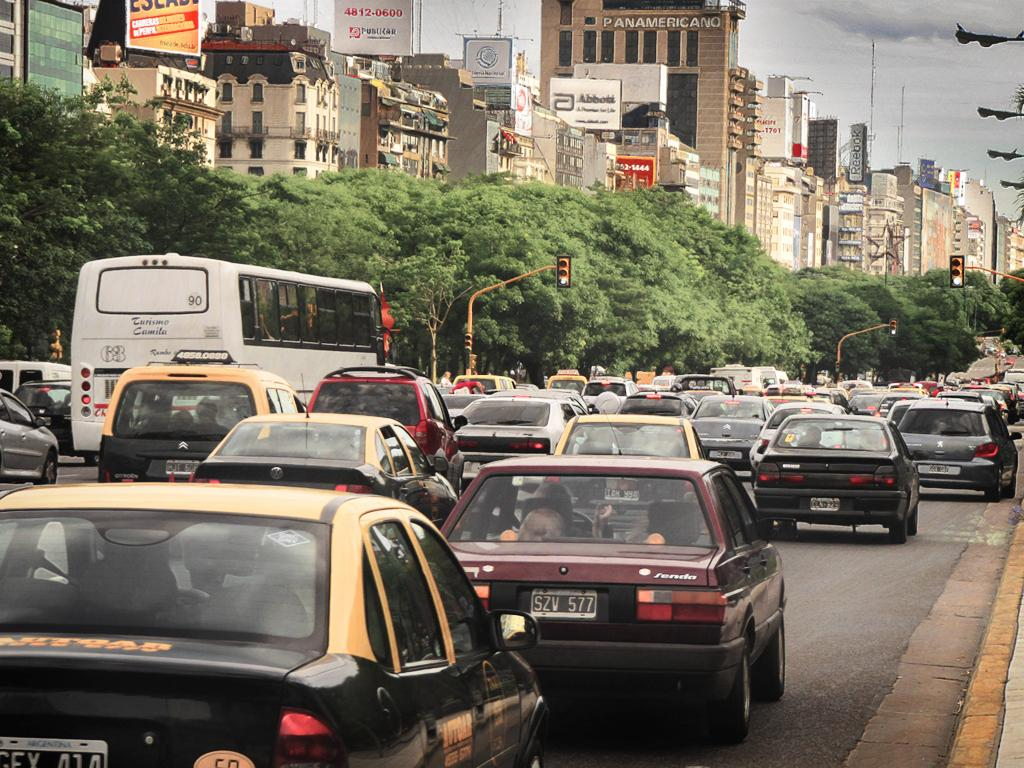<image>
Render a clear and concise summary of the photo. Busy traffic is driving on a street with the Panamericano building on it. 